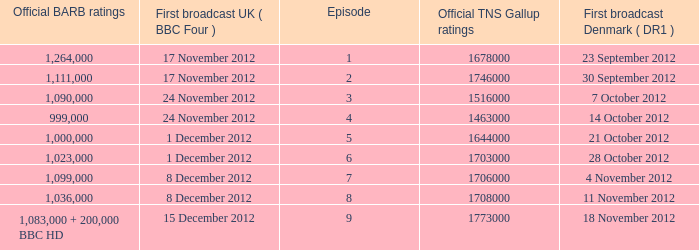When was the episode with a 999,000 BARB rating first aired in Denmark? 14 October 2012. 